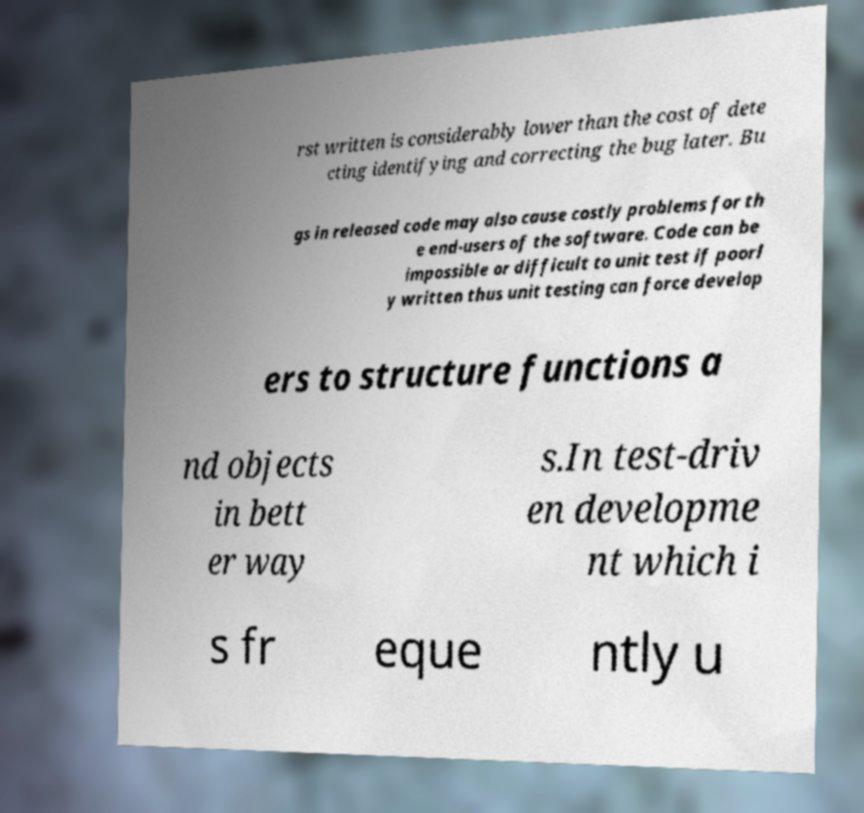Please identify and transcribe the text found in this image. rst written is considerably lower than the cost of dete cting identifying and correcting the bug later. Bu gs in released code may also cause costly problems for th e end-users of the software. Code can be impossible or difficult to unit test if poorl y written thus unit testing can force develop ers to structure functions a nd objects in bett er way s.In test-driv en developme nt which i s fr eque ntly u 